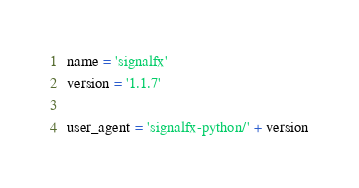Convert code to text. <code><loc_0><loc_0><loc_500><loc_500><_Python_>name = 'signalfx'
version = '1.1.7'

user_agent = 'signalfx-python/' + version
</code> 